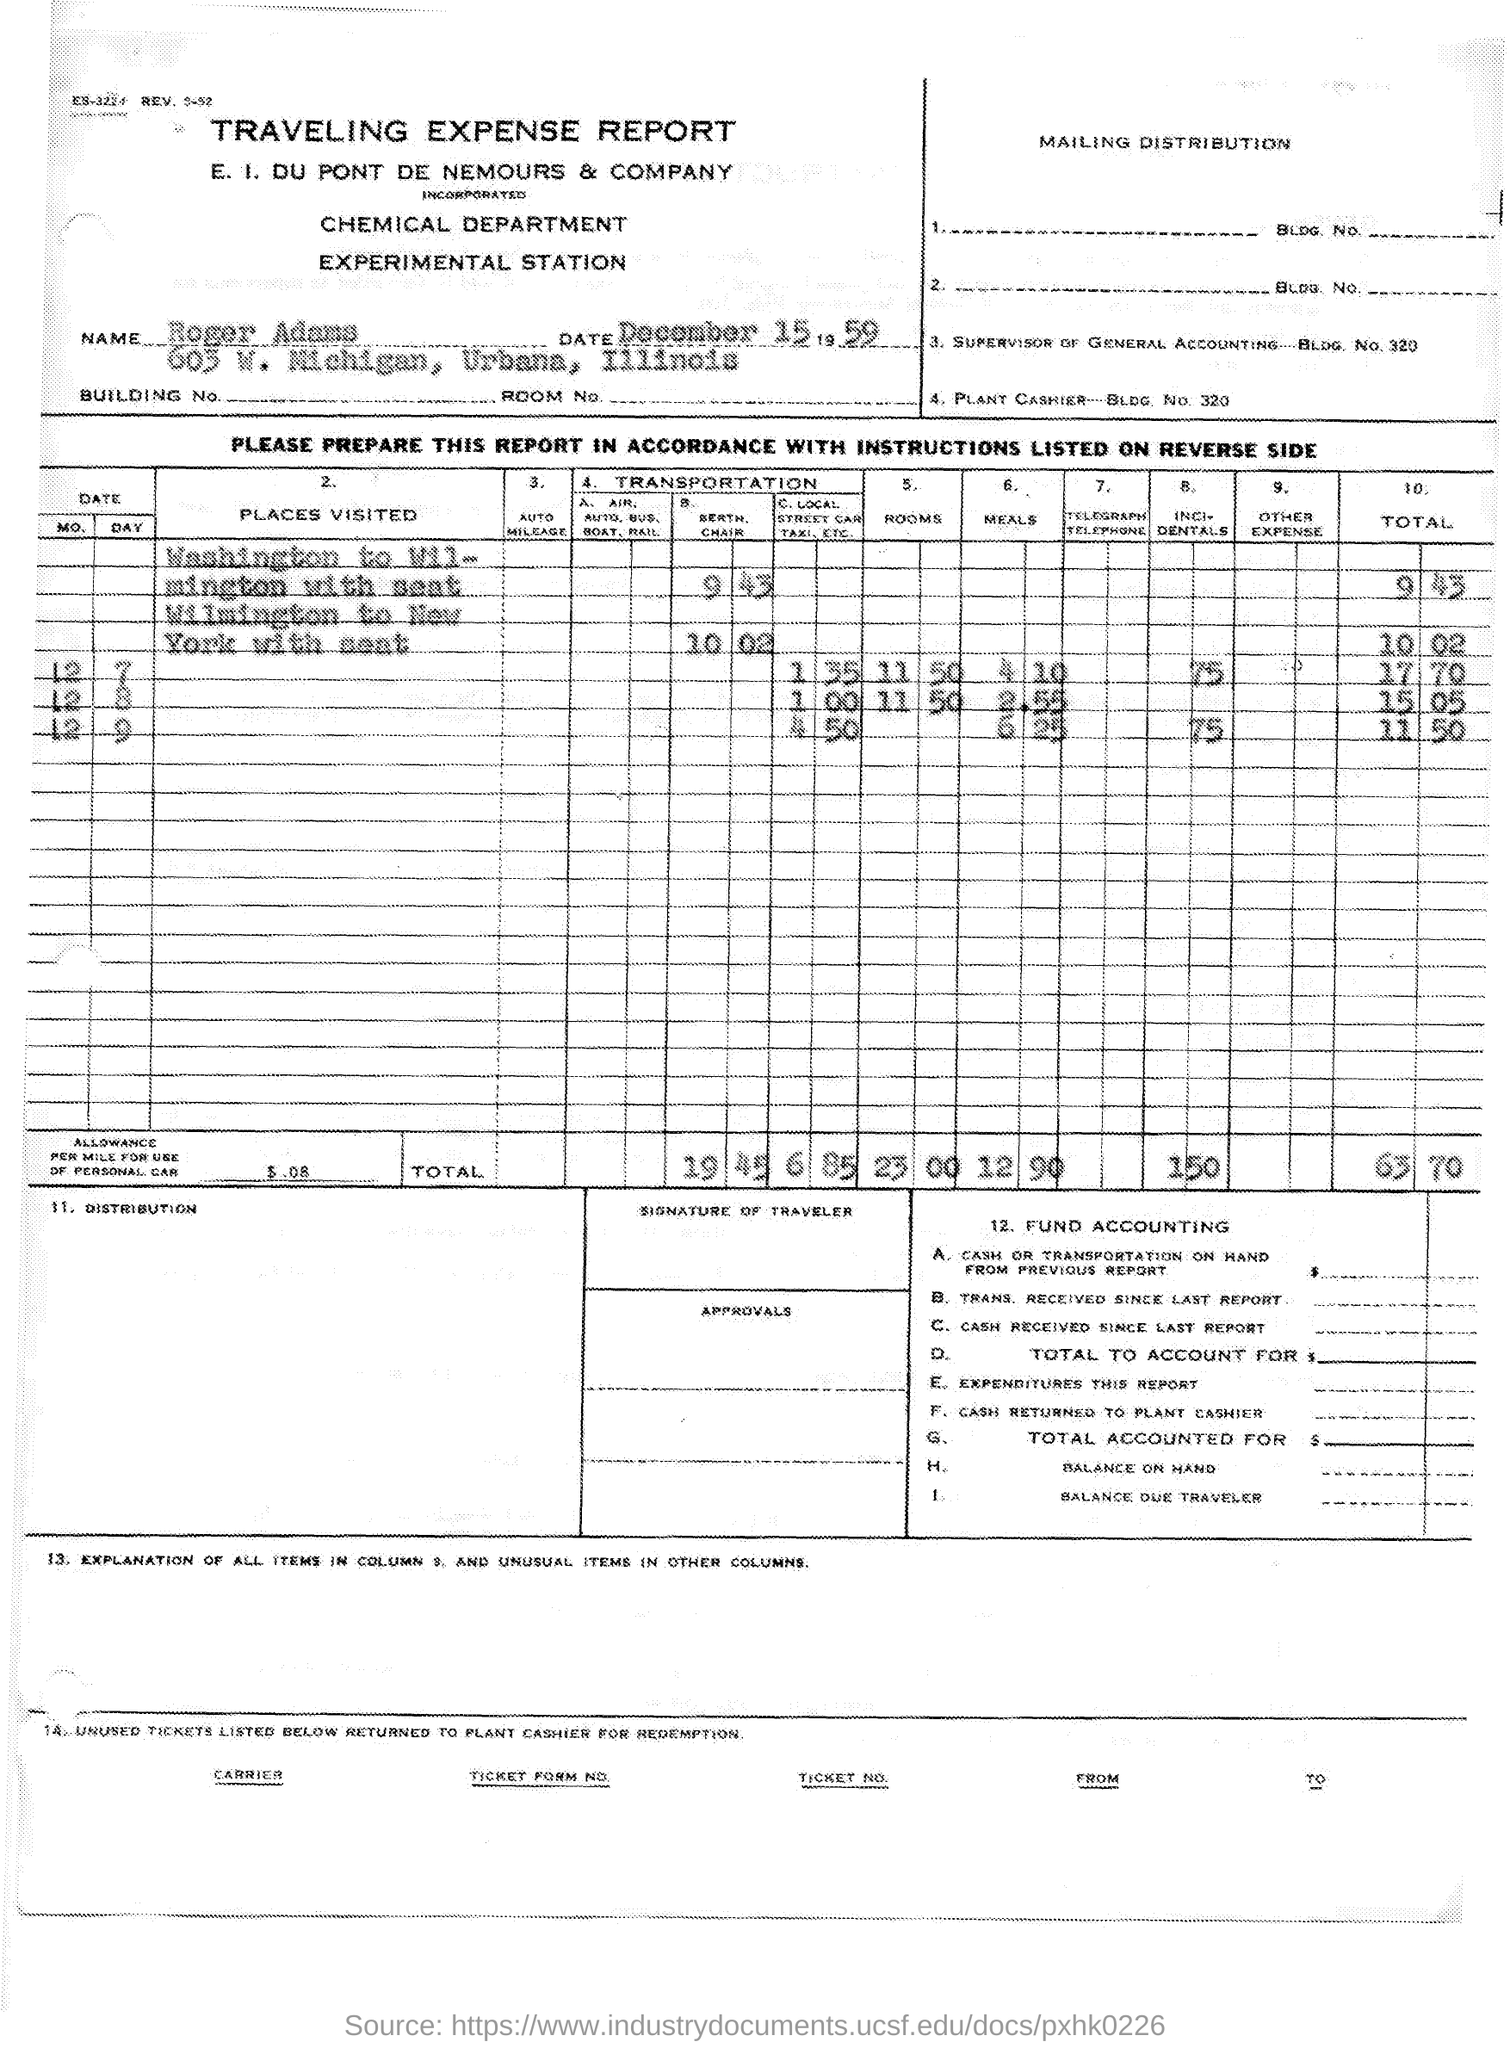Outline some significant characteristics in this image. The date is December 15, 1959. The document pertains to a Traveling Expense Report. The total amount is 63 and 70. 